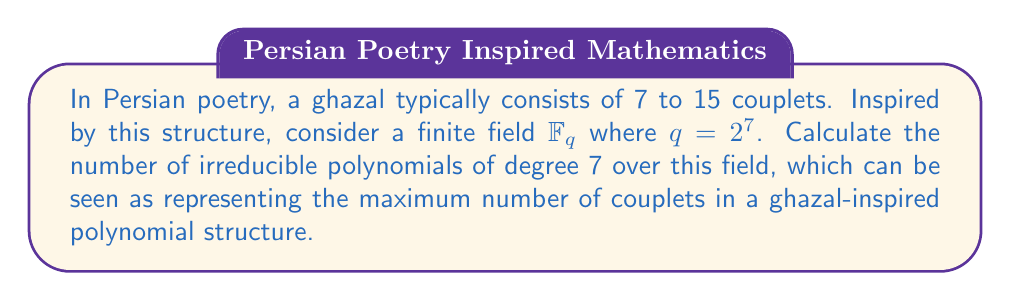Show me your answer to this math problem. To solve this problem, we'll follow these steps:

1) First, recall the formula for the number of monic irreducible polynomials of degree $n$ over $\mathbb{F}_q$:

   $$N_q(n) = \frac{1}{n} \sum_{d|n} \mu(d)q^{n/d}$$

   where $\mu(d)$ is the Möbius function.

2) In our case, $q = 2^7 = 128$ and $n = 7$. The divisors of 7 are 1 and 7.

3) Calculate the Möbius function values:
   $\mu(1) = 1$
   $\mu(7) = -1$ (as 7 is prime)

4) Now, let's substitute these into our formula:

   $$N_{128}(7) = \frac{1}{7} [\mu(1)(128^{7/1}) + \mu(7)(128^{7/7})]$$

5) Simplify:
   $$N_{128}(7) = \frac{1}{7} [128^7 - 128]$$

6) Calculate $128^7$:
   $$128^7 = 2^{49} = 562,949,953,421,312$$

7) Substitute and calculate:
   $$N_{128}(7) = \frac{1}{7} [562,949,953,421,312 - 128]$$
   $$= \frac{562,949,953,421,184}{7}$$
   $$= 80,421,421,917,312$$

Thus, there are 80,421,421,917,312 irreducible polynomials of degree 7 over $\mathbb{F}_{128}$.
Answer: 80,421,421,917,312 